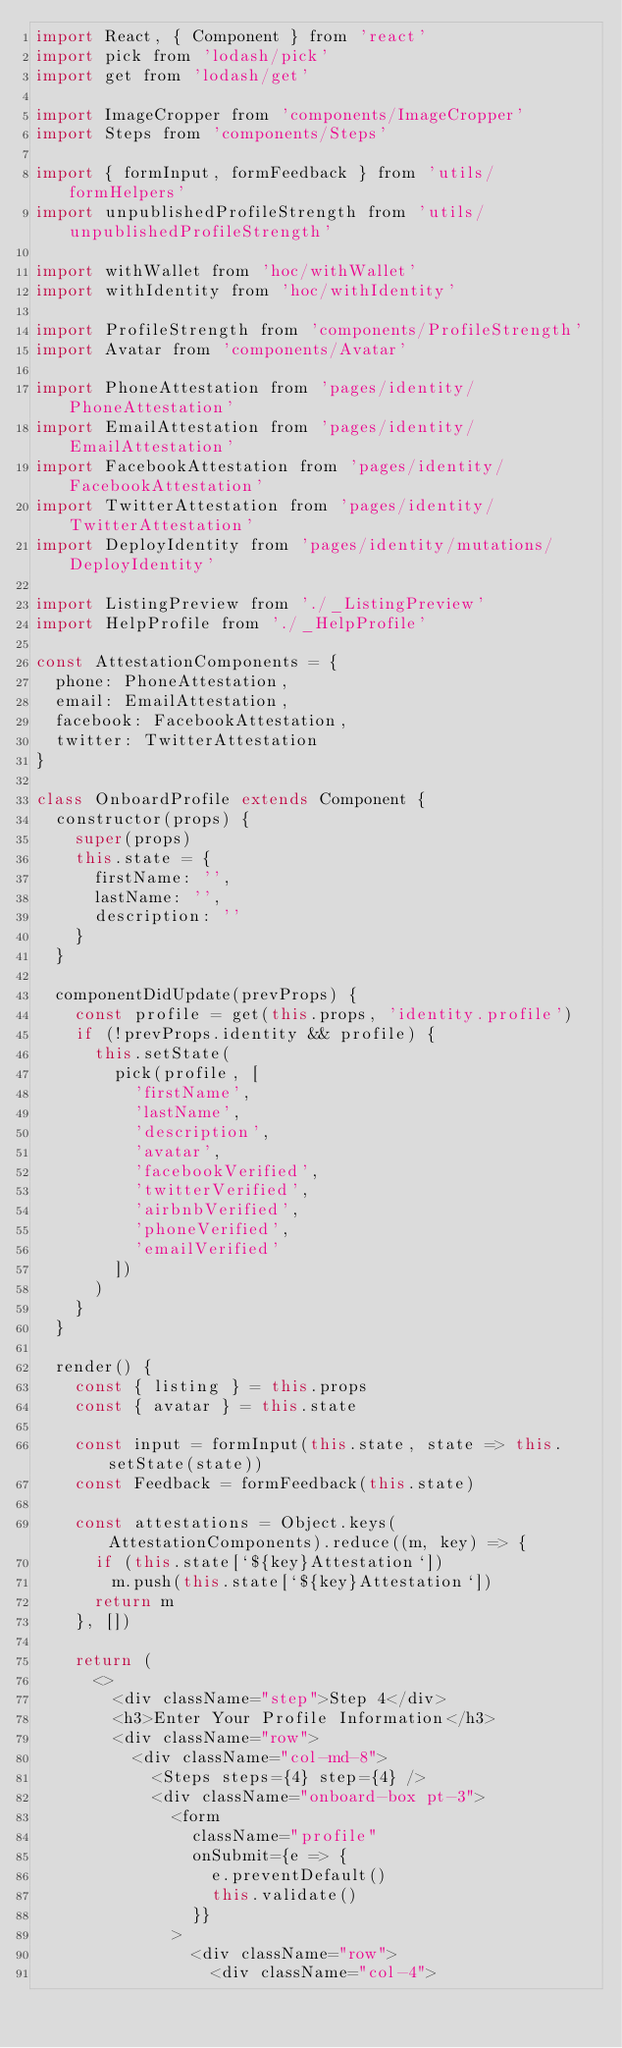<code> <loc_0><loc_0><loc_500><loc_500><_JavaScript_>import React, { Component } from 'react'
import pick from 'lodash/pick'
import get from 'lodash/get'

import ImageCropper from 'components/ImageCropper'
import Steps from 'components/Steps'

import { formInput, formFeedback } from 'utils/formHelpers'
import unpublishedProfileStrength from 'utils/unpublishedProfileStrength'

import withWallet from 'hoc/withWallet'
import withIdentity from 'hoc/withIdentity'

import ProfileStrength from 'components/ProfileStrength'
import Avatar from 'components/Avatar'

import PhoneAttestation from 'pages/identity/PhoneAttestation'
import EmailAttestation from 'pages/identity/EmailAttestation'
import FacebookAttestation from 'pages/identity/FacebookAttestation'
import TwitterAttestation from 'pages/identity/TwitterAttestation'
import DeployIdentity from 'pages/identity/mutations/DeployIdentity'

import ListingPreview from './_ListingPreview'
import HelpProfile from './_HelpProfile'

const AttestationComponents = {
  phone: PhoneAttestation,
  email: EmailAttestation,
  facebook: FacebookAttestation,
  twitter: TwitterAttestation
}

class OnboardProfile extends Component {
  constructor(props) {
    super(props)
    this.state = {
      firstName: '',
      lastName: '',
      description: ''
    }
  }

  componentDidUpdate(prevProps) {
    const profile = get(this.props, 'identity.profile')
    if (!prevProps.identity && profile) {
      this.setState(
        pick(profile, [
          'firstName',
          'lastName',
          'description',
          'avatar',
          'facebookVerified',
          'twitterVerified',
          'airbnbVerified',
          'phoneVerified',
          'emailVerified'
        ])
      )
    }
  }

  render() {
    const { listing } = this.props
    const { avatar } = this.state

    const input = formInput(this.state, state => this.setState(state))
    const Feedback = formFeedback(this.state)

    const attestations = Object.keys(AttestationComponents).reduce((m, key) => {
      if (this.state[`${key}Attestation`])
        m.push(this.state[`${key}Attestation`])
      return m
    }, [])

    return (
      <>
        <div className="step">Step 4</div>
        <h3>Enter Your Profile Information</h3>
        <div className="row">
          <div className="col-md-8">
            <Steps steps={4} step={4} />
            <div className="onboard-box pt-3">
              <form
                className="profile"
                onSubmit={e => {
                  e.preventDefault()
                  this.validate()
                }}
              >
                <div className="row">
                  <div className="col-4"></code> 